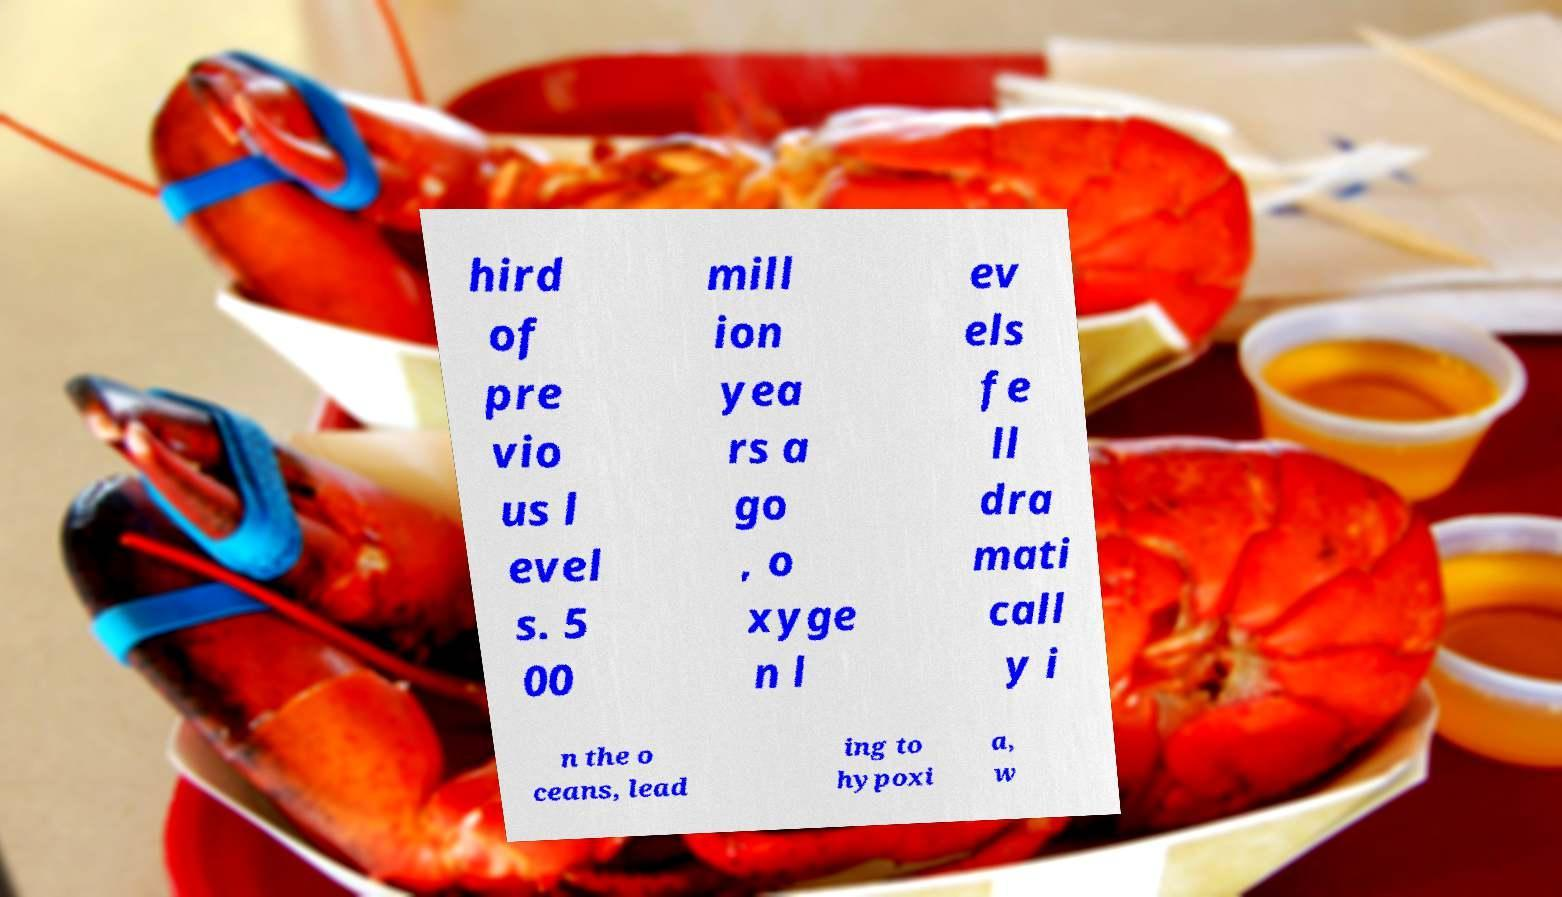Could you extract and type out the text from this image? hird of pre vio us l evel s. 5 00 mill ion yea rs a go , o xyge n l ev els fe ll dra mati call y i n the o ceans, lead ing to hypoxi a, w 